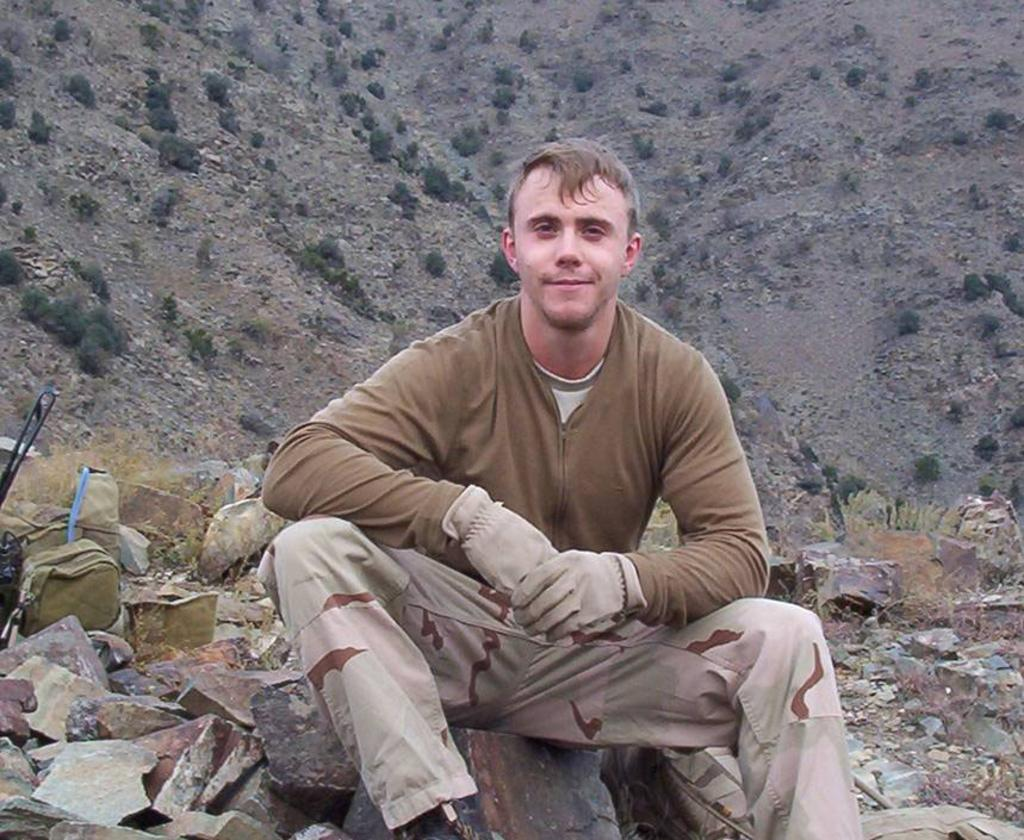What is the person in the image doing? There is a person sitting in the image. What type of natural features can be seen in the image? There are rocks and a mountain in the image. What objects are present in the image? There is a bag and plants in the image. What type of coal is being mined in the scene? There is no coal or mining activity present in the image. 